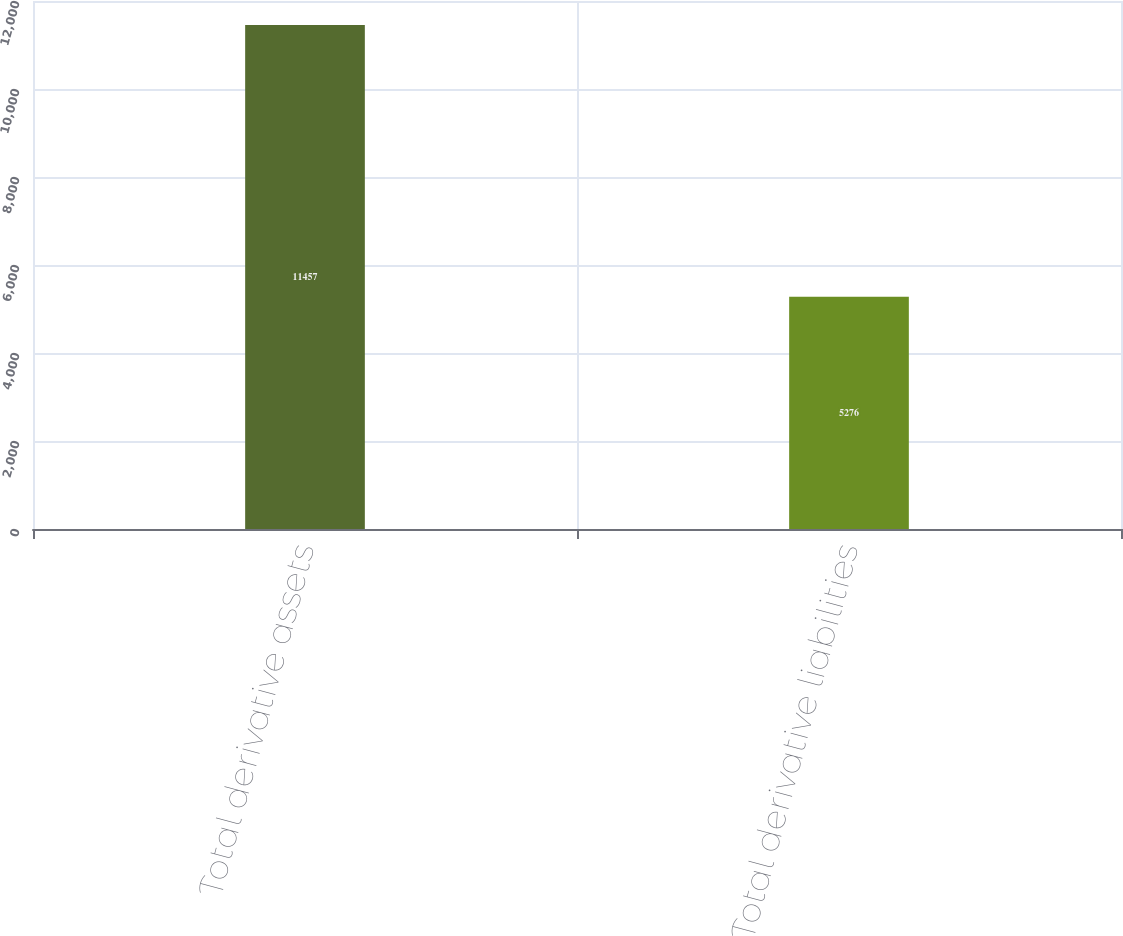Convert chart to OTSL. <chart><loc_0><loc_0><loc_500><loc_500><bar_chart><fcel>Total derivative assets<fcel>Total derivative liabilities<nl><fcel>11457<fcel>5276<nl></chart> 